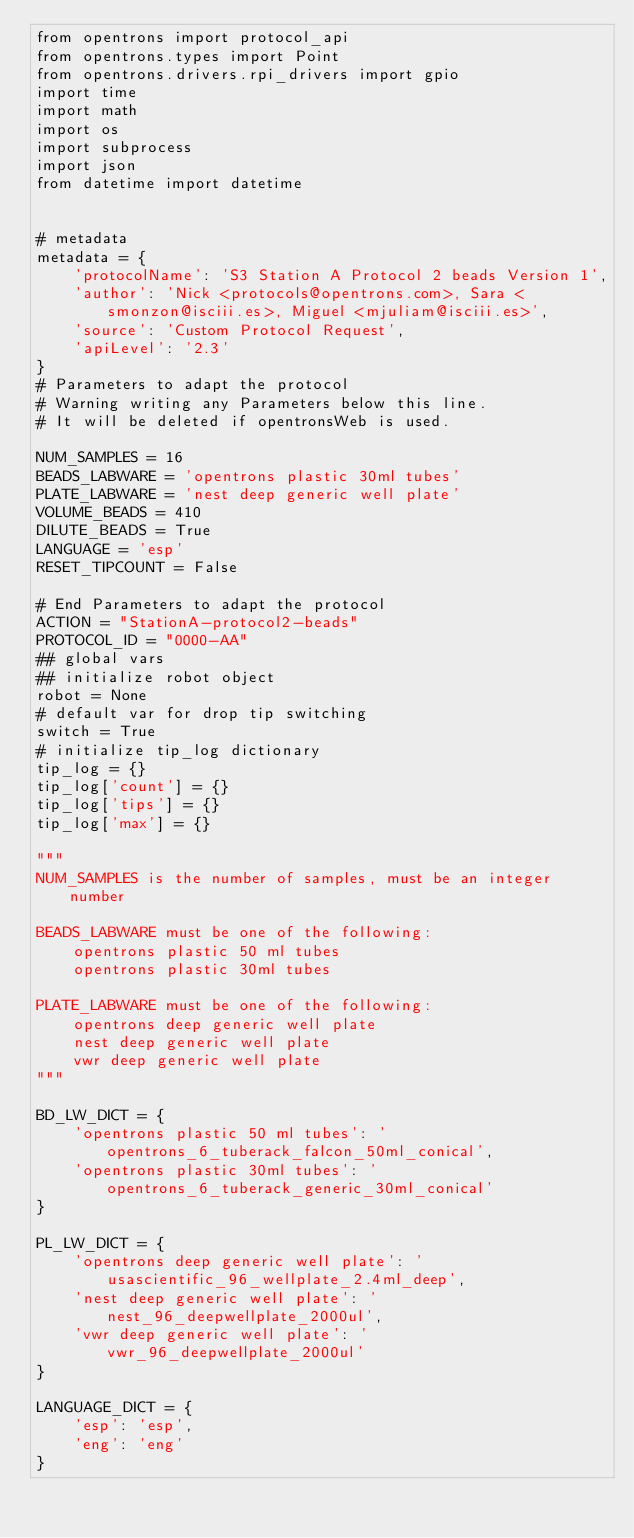Convert code to text. <code><loc_0><loc_0><loc_500><loc_500><_Python_>from opentrons import protocol_api
from opentrons.types import Point
from opentrons.drivers.rpi_drivers import gpio
import time
import math
import os
import subprocess
import json
from datetime import datetime


# metadata
metadata = {
    'protocolName': 'S3 Station A Protocol 2 beads Version 1',
    'author': 'Nick <protocols@opentrons.com>, Sara <smonzon@isciii.es>, Miguel <mjuliam@isciii.es>',
    'source': 'Custom Protocol Request',
    'apiLevel': '2.3'
}
# Parameters to adapt the protocol
# Warning writing any Parameters below this line.
# It will be deleted if opentronsWeb is used.

NUM_SAMPLES = 16
BEADS_LABWARE = 'opentrons plastic 30ml tubes'
PLATE_LABWARE = 'nest deep generic well plate'
VOLUME_BEADS = 410
DILUTE_BEADS = True
LANGUAGE = 'esp'
RESET_TIPCOUNT = False

# End Parameters to adapt the protocol
ACTION = "StationA-protocol2-beads"
PROTOCOL_ID = "0000-AA"
## global vars
## initialize robot object
robot = None
# default var for drop tip switching
switch = True
# initialize tip_log dictionary
tip_log = {}
tip_log['count'] = {}
tip_log['tips'] = {}
tip_log['max'] = {}

"""
NUM_SAMPLES is the number of samples, must be an integer number

BEADS_LABWARE must be one of the following:
    opentrons plastic 50 ml tubes
    opentrons plastic 30ml tubes

PLATE_LABWARE must be one of the following:
    opentrons deep generic well plate
    nest deep generic well plate
    vwr deep generic well plate
"""

BD_LW_DICT = {
    'opentrons plastic 50 ml tubes': 'opentrons_6_tuberack_falcon_50ml_conical',
    'opentrons plastic 30ml tubes': 'opentrons_6_tuberack_generic_30ml_conical'
}

PL_LW_DICT = {
    'opentrons deep generic well plate': 'usascientific_96_wellplate_2.4ml_deep',
    'nest deep generic well plate': 'nest_96_deepwellplate_2000ul',
    'vwr deep generic well plate': 'vwr_96_deepwellplate_2000ul'
}

LANGUAGE_DICT = {
    'esp': 'esp',
    'eng': 'eng'
}
</code> 